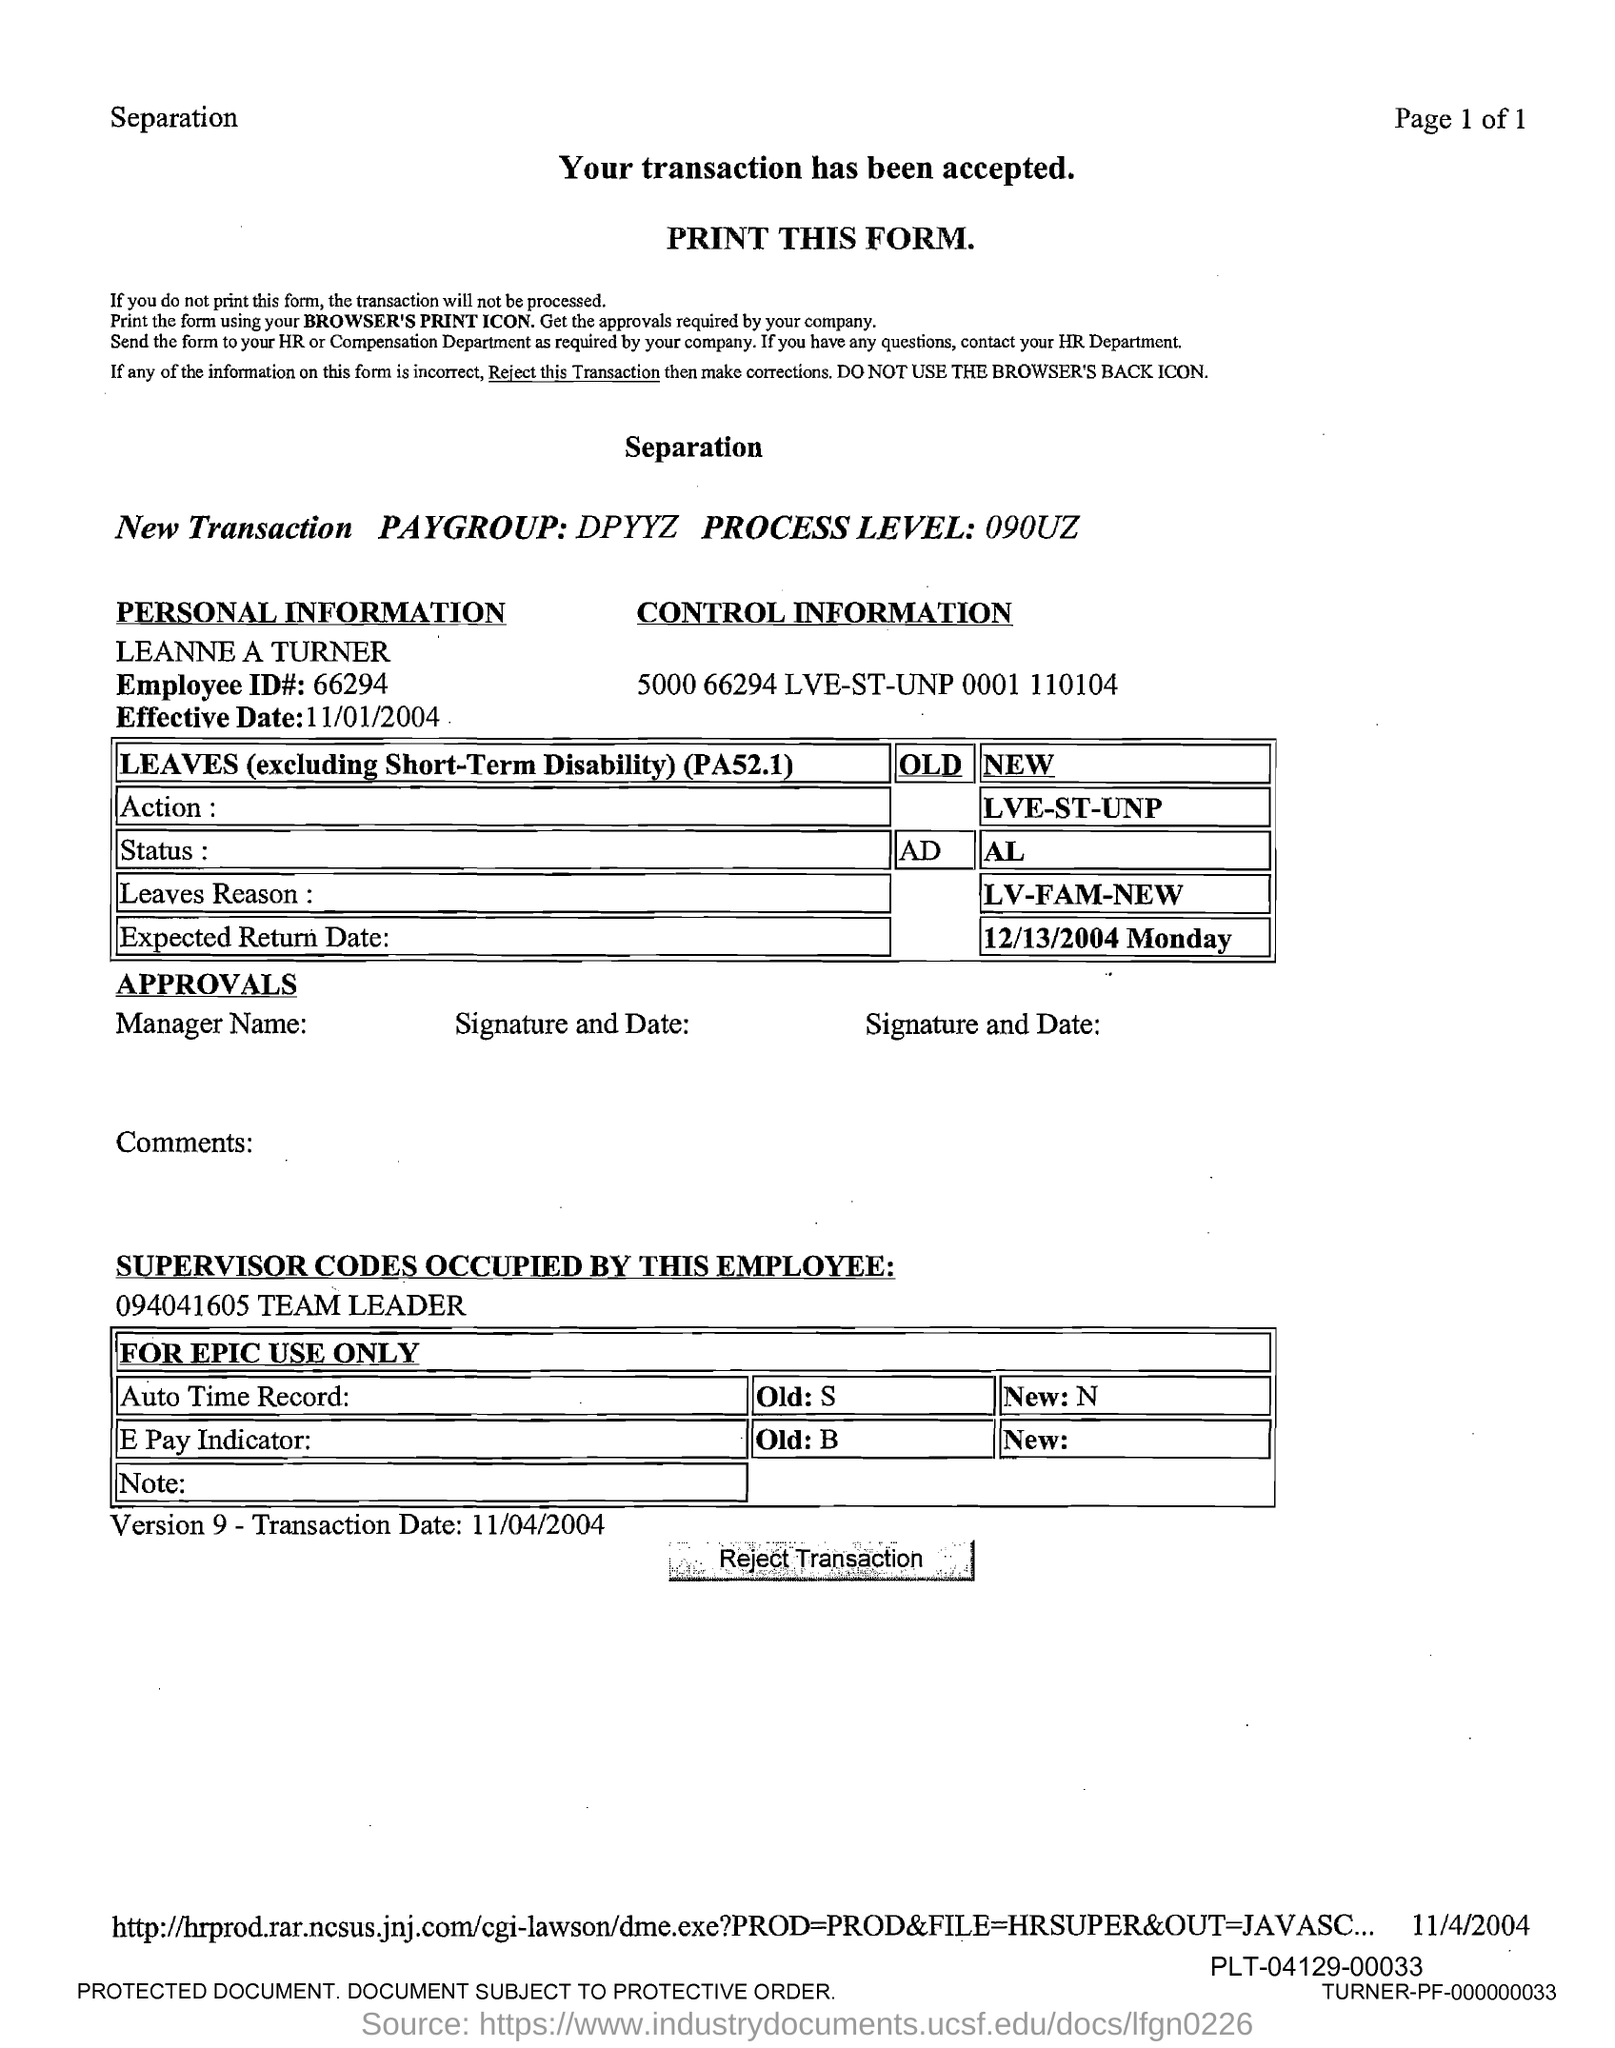Outline some significant characteristics in this image. What is the effective date? It is November 1, 2004. What is the employee ID number? It is 66294... 